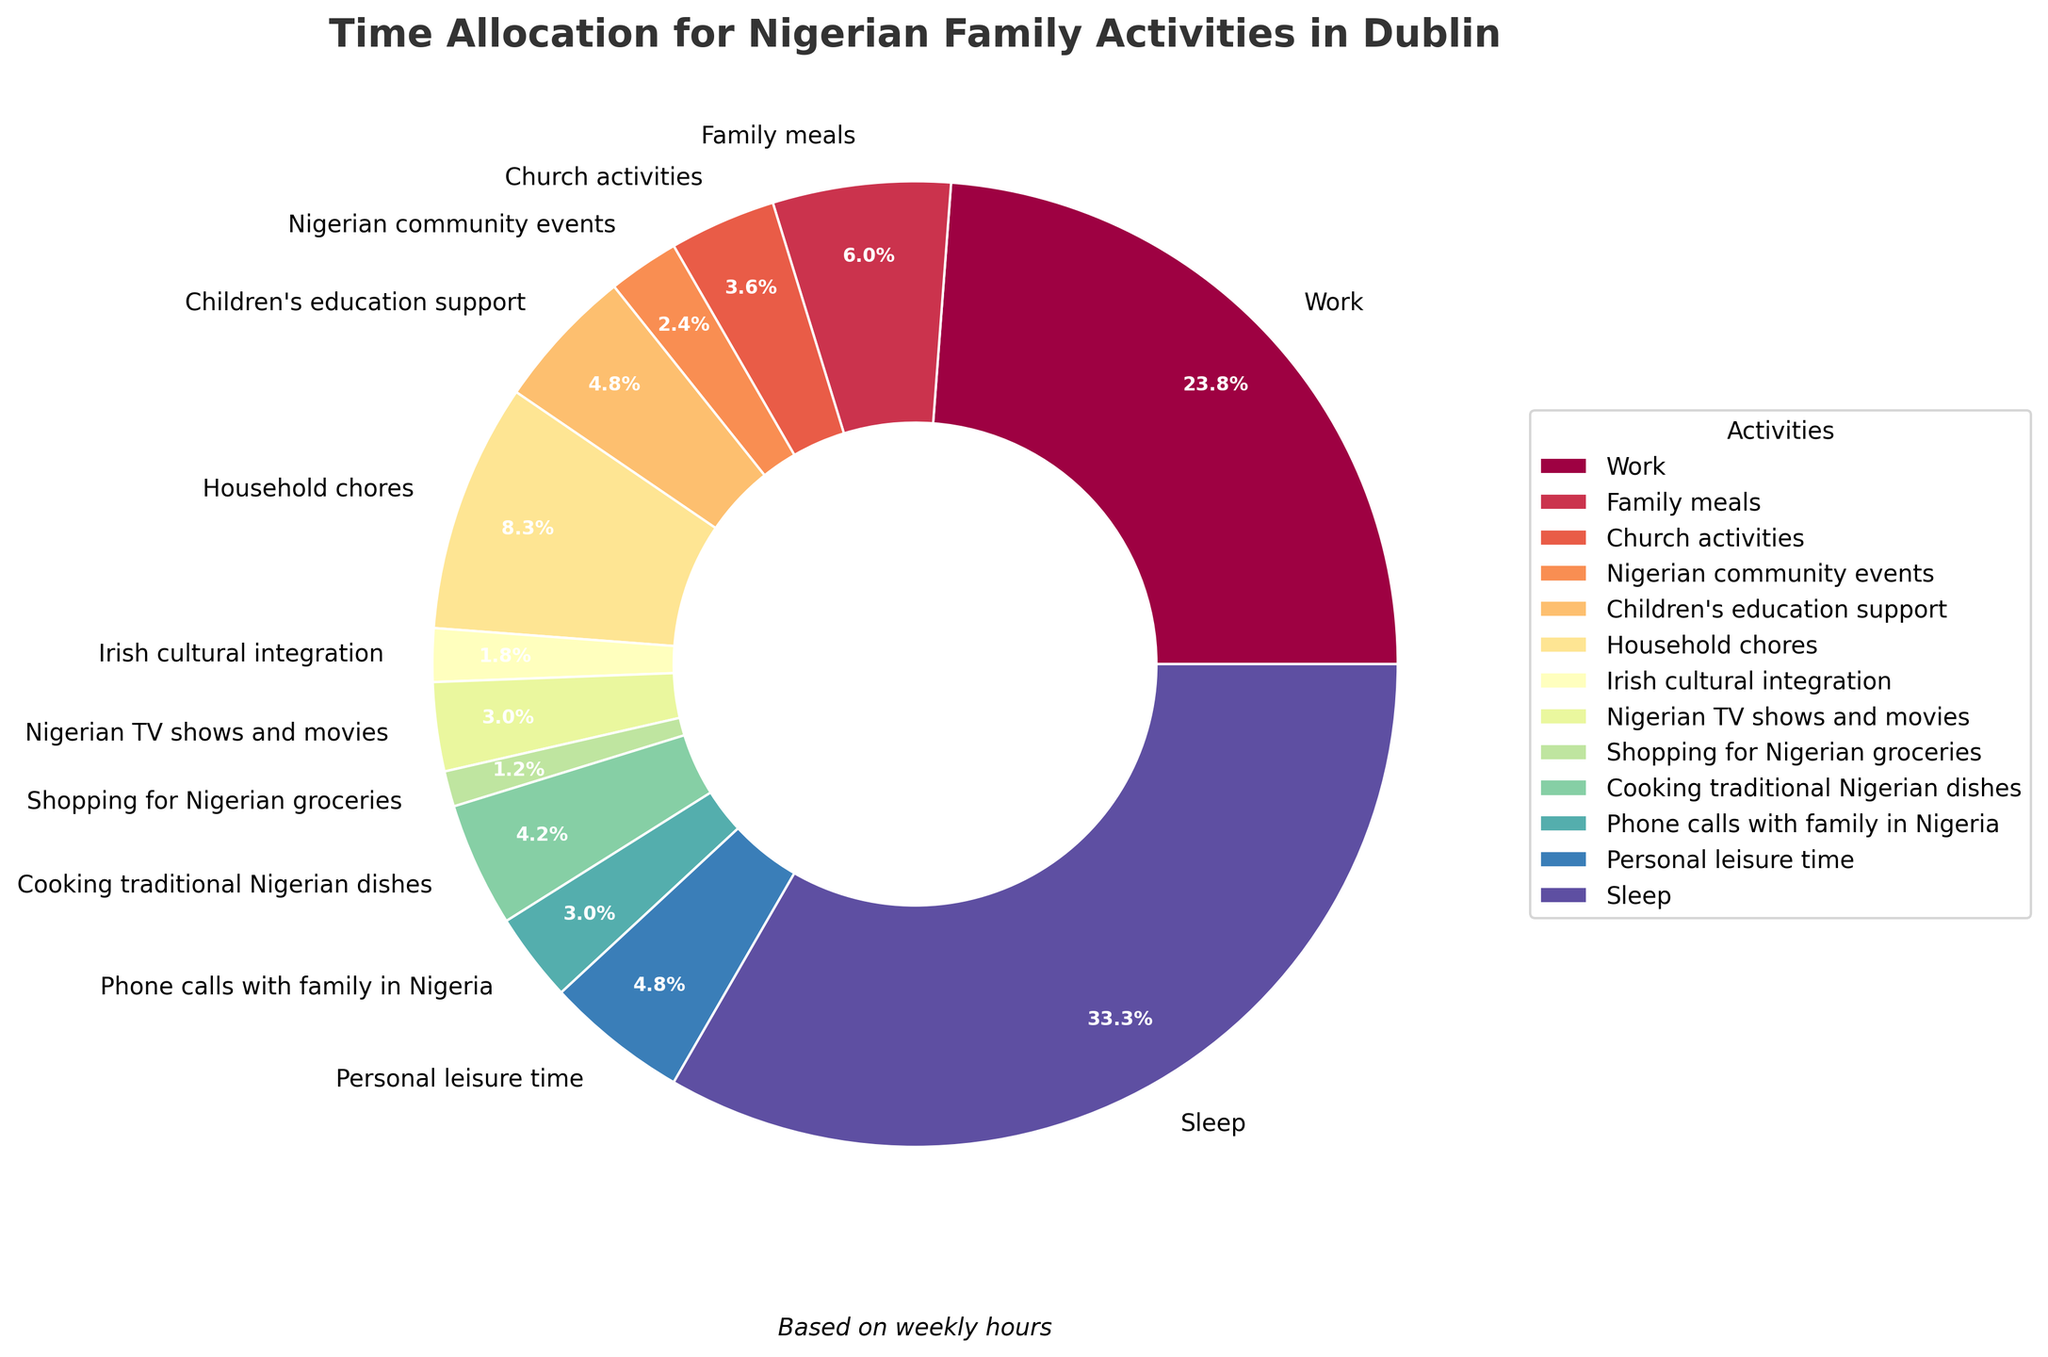What's the percentage of time spent on children's education support? To find the percentage of time spent on children's education support, look at the pie chart segment labeled "Children's education support". The value next to the label shows 8.5%.
Answer: 8.5% Is more time spent on work or sleep? Compare the sections of the pie chart corresponding to "Work" and "Sleep". "Work" takes up 23.8%, while "Sleep" takes up 33.3%. Since 33.3% is greater than 23.8%, more time is spent on sleep.
Answer: Sleep How much more time is spent on family meals compared to Nigerian TV shows and movies? Look at the pie chart segments labeled "Family meals" and "Nigerian TV shows and movies". "Family meals" account for 6.0%, and "Nigerian TV shows and movies" account for 3.0%. The difference is 6.0% - 3.0% = 3.0%.
Answer: 3.0% Which activity has the smallest allocation of time? Identify the smallest segment in the pie chart. This segment is labeled "Shopping for Nigerian groceries", which shows 1.2%.
Answer: Shopping for Nigerian groceries What is the total percentage of time spent on work, household chores, and personal leisure time combined? Look at the pie chart segments for "Work", "Household chores", and "Personal leisure time". Add their percentages: 23.8% (Work) + 8.3% (Household chores) + 4.8% (Personal leisure time) = 36.9%.
Answer: 36.9% Which is more prominent, Nigerian community events or Irish cultural integration? Compare the segments labeled "Nigerian community events" and "Irish cultural integration". "Nigerian community events" accounts for 2.4%, while "Irish cultural integration" accounts for 1.8%. Since 2.4% is greater than 1.8%, Nigerian community events are more prominent.
Answer: Nigerian community events What color represents the Church activities segment? Look at the segment labeled "Church activities" in the pie chart and observe its color. The segment is a shade of purple.
Answer: Purple What's the difference in the percentage of time spent on cooking traditional Nigerian dishes compared to phone calls with family in Nigeria? Look at the pie chart segments labeled "Cooking traditional Nigerian dishes" and "Phone calls with family in Nigeria". "Cooking traditional Nigerian dishes" accounts for 4.2% and "Phone calls with family in Nigeria" accounts for 3.0%. The difference is 4.2% - 3.0% = 1.2%.
Answer: 1.2% Which activity is represented by the largest segment in the pie chart? Identify the largest segment in the pie chart. This segment is labeled "Sleep", which shows 33.3%.
Answer: Sleep 